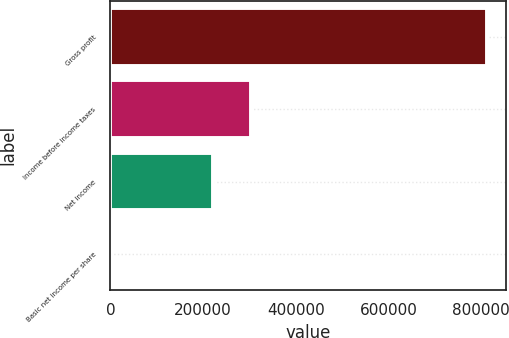Convert chart to OTSL. <chart><loc_0><loc_0><loc_500><loc_500><bar_chart><fcel>Gross profit<fcel>Income before income taxes<fcel>Net income<fcel>Basic net income per share<nl><fcel>812615<fcel>303469<fcel>222208<fcel>0.39<nl></chart> 